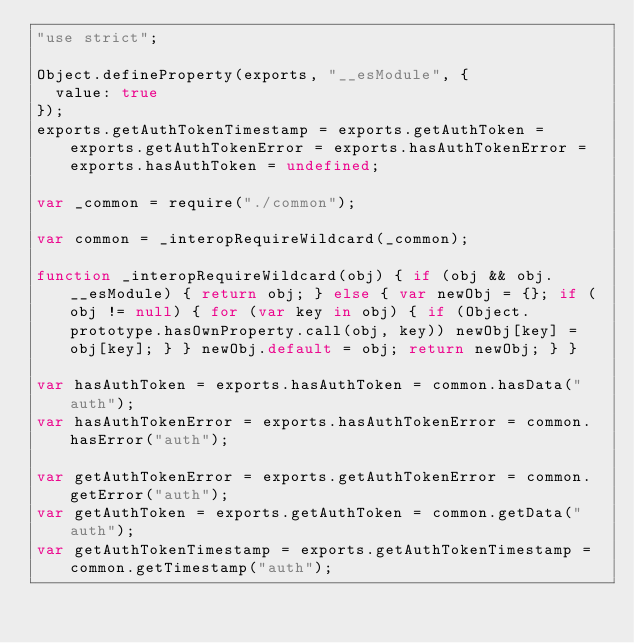<code> <loc_0><loc_0><loc_500><loc_500><_JavaScript_>"use strict";

Object.defineProperty(exports, "__esModule", {
  value: true
});
exports.getAuthTokenTimestamp = exports.getAuthToken = exports.getAuthTokenError = exports.hasAuthTokenError = exports.hasAuthToken = undefined;

var _common = require("./common");

var common = _interopRequireWildcard(_common);

function _interopRequireWildcard(obj) { if (obj && obj.__esModule) { return obj; } else { var newObj = {}; if (obj != null) { for (var key in obj) { if (Object.prototype.hasOwnProperty.call(obj, key)) newObj[key] = obj[key]; } } newObj.default = obj; return newObj; } }

var hasAuthToken = exports.hasAuthToken = common.hasData("auth");
var hasAuthTokenError = exports.hasAuthTokenError = common.hasError("auth");

var getAuthTokenError = exports.getAuthTokenError = common.getError("auth");
var getAuthToken = exports.getAuthToken = common.getData("auth");
var getAuthTokenTimestamp = exports.getAuthTokenTimestamp = common.getTimestamp("auth");</code> 